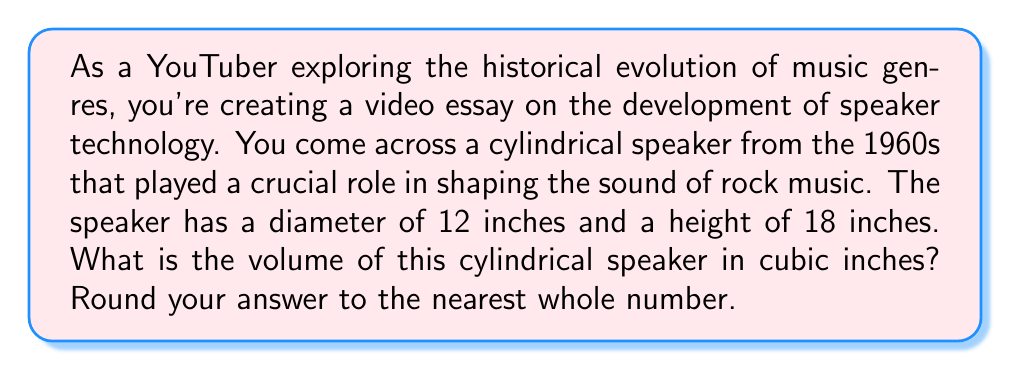Could you help me with this problem? To find the volume of a cylindrical speaker, we need to use the formula for the volume of a cylinder:

$$V = \pi r^2 h$$

Where:
$V$ = volume
$r$ = radius of the base
$h$ = height of the cylinder

Given:
- Diameter = 12 inches
- Height = 18 inches

Step 1: Calculate the radius
The radius is half the diameter:
$r = \frac{12}{2} = 6$ inches

Step 2: Apply the volume formula
$$V = \pi (6\text{ in})^2 (18\text{ in})$$

Step 3: Calculate
$$\begin{align*}
V &= \pi (36\text{ in}^2) (18\text{ in}) \\
&= 648\pi\text{ in}^3 \\
&\approx 2,036.18\text{ in}^3
\end{align*}$$

Step 4: Round to the nearest whole number
$2,036\text{ in}^3$

[asy]
import geometry;

size(200);
real r = 3;
real h = 4.5;

path base = circle((0,0), r);
path top = circle((0,h), r);

draw(base);
draw(top);
draw((r,0)--(r,h));
draw((-r,0)--(-r,h));

label("r", (r/2,0), E);
label("h", (r,h/2), E);

draw((0,0)--(r,0), arrow=Arrow(TeXHead));
draw((r,0)--(r,h), arrow=Arrow(TeXHead));
[/asy]
Answer: The volume of the cylindrical speaker is approximately 2,036 cubic inches. 